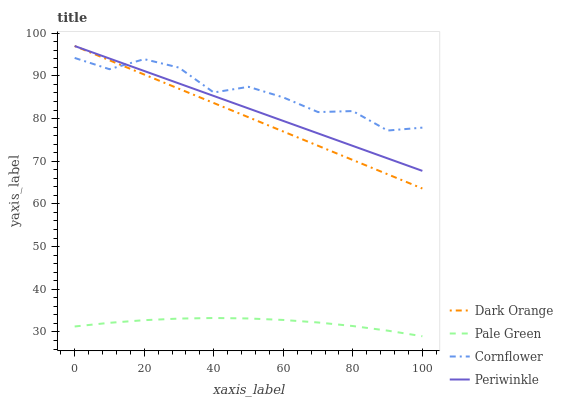Does Periwinkle have the minimum area under the curve?
Answer yes or no. No. Does Periwinkle have the maximum area under the curve?
Answer yes or no. No. Is Pale Green the smoothest?
Answer yes or no. No. Is Pale Green the roughest?
Answer yes or no. No. Does Periwinkle have the lowest value?
Answer yes or no. No. Does Pale Green have the highest value?
Answer yes or no. No. Is Pale Green less than Periwinkle?
Answer yes or no. Yes. Is Periwinkle greater than Pale Green?
Answer yes or no. Yes. Does Pale Green intersect Periwinkle?
Answer yes or no. No. 